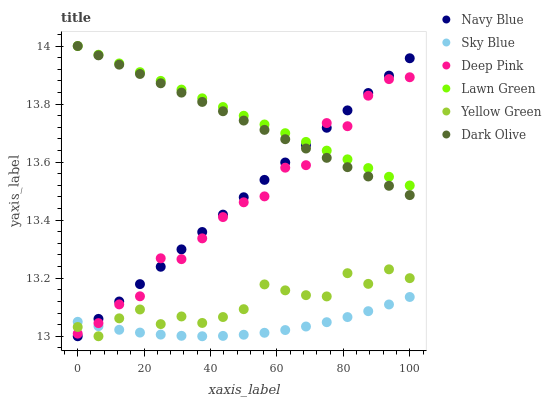Does Sky Blue have the minimum area under the curve?
Answer yes or no. Yes. Does Lawn Green have the maximum area under the curve?
Answer yes or no. Yes. Does Deep Pink have the minimum area under the curve?
Answer yes or no. No. Does Deep Pink have the maximum area under the curve?
Answer yes or no. No. Is Navy Blue the smoothest?
Answer yes or no. Yes. Is Deep Pink the roughest?
Answer yes or no. Yes. Is Yellow Green the smoothest?
Answer yes or no. No. Is Yellow Green the roughest?
Answer yes or no. No. Does Yellow Green have the lowest value?
Answer yes or no. Yes. Does Deep Pink have the lowest value?
Answer yes or no. No. Does Dark Olive have the highest value?
Answer yes or no. Yes. Does Deep Pink have the highest value?
Answer yes or no. No. Is Yellow Green less than Dark Olive?
Answer yes or no. Yes. Is Dark Olive greater than Sky Blue?
Answer yes or no. Yes. Does Dark Olive intersect Lawn Green?
Answer yes or no. Yes. Is Dark Olive less than Lawn Green?
Answer yes or no. No. Is Dark Olive greater than Lawn Green?
Answer yes or no. No. Does Yellow Green intersect Dark Olive?
Answer yes or no. No. 